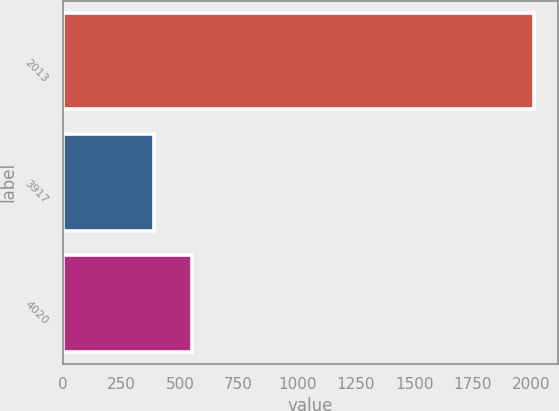Convert chart to OTSL. <chart><loc_0><loc_0><loc_500><loc_500><bar_chart><fcel>2013<fcel>3917<fcel>4020<nl><fcel>2013<fcel>389.1<fcel>551.49<nl></chart> 